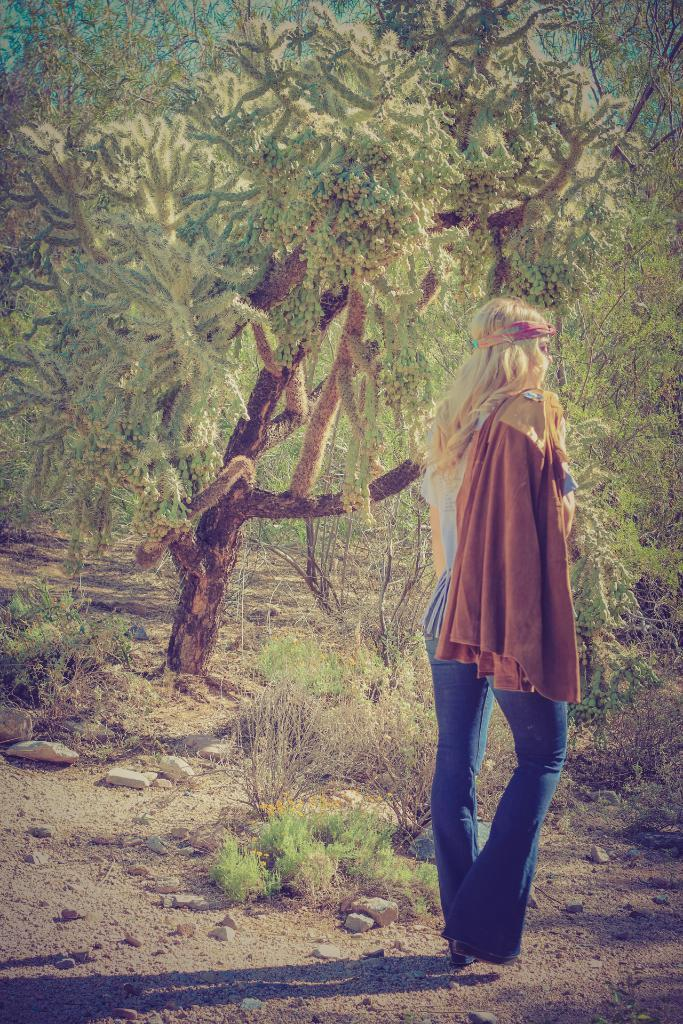What type of vegetation can be seen in the image? There are trees in the image. What else can be seen on the ground in the image? There is grass in the image. Who is present in the image? There is a woman in the image. What is the woman holding in the image? The woman is holding a brown color jacket. What is the title of the book the woman is reading in the image? There is no book present in the image, so it is not possible to determine the title. 